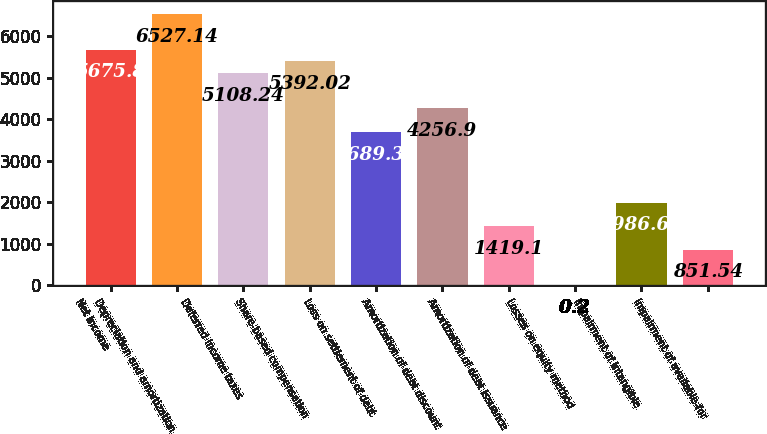<chart> <loc_0><loc_0><loc_500><loc_500><bar_chart><fcel>Net income<fcel>Depreciation and amortization<fcel>Deferred income taxes<fcel>Share-based compensation<fcel>Loss on settlement of debt<fcel>Amortization of debt discount<fcel>Amortization of debt issuance<fcel>Losses on equity method<fcel>Impairment of intangible<fcel>Impairment of available-for<nl><fcel>5675.8<fcel>6527.14<fcel>5108.24<fcel>5392.02<fcel>3689.34<fcel>4256.9<fcel>1419.1<fcel>0.2<fcel>1986.66<fcel>851.54<nl></chart> 